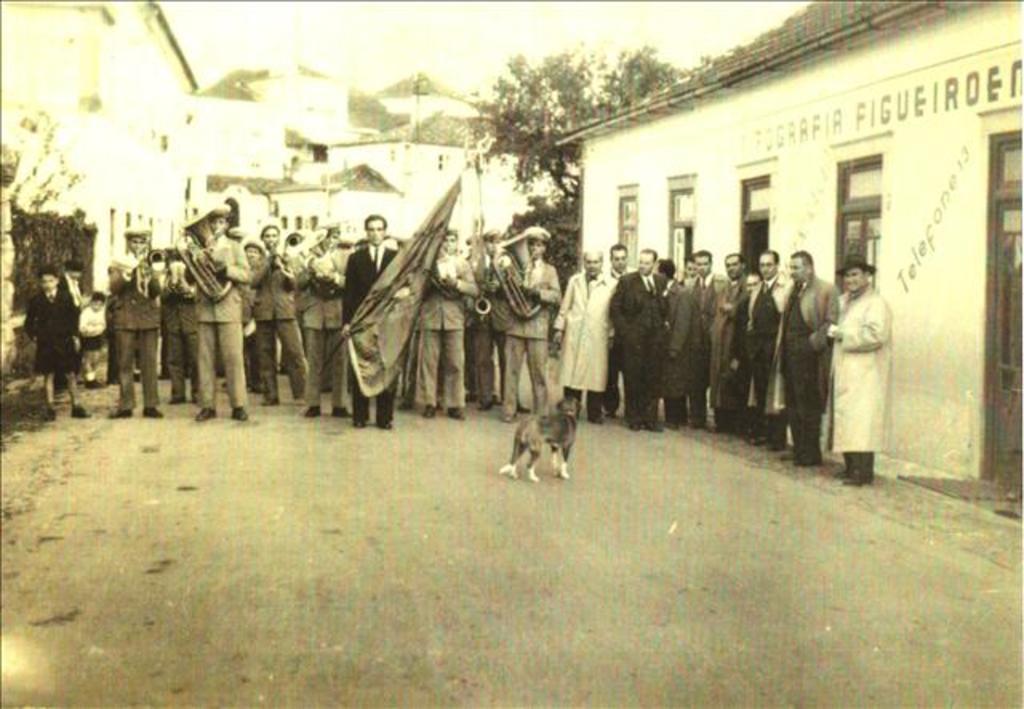Can you describe this image briefly? In this image we can see a group of people standing on the road. In that some are holding the flags and trumpets. We can also see a dog in front of them. On the backside we can see some houses with roof, windows and a name board, some trees and the sky. 